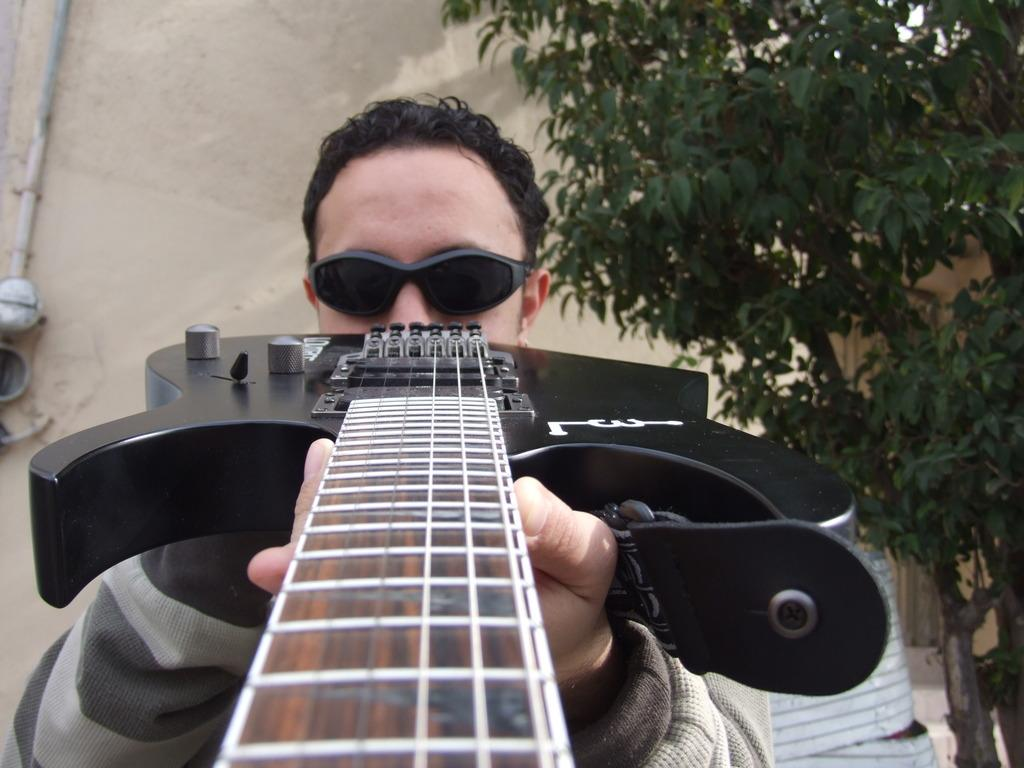What is the main subject of the image? There is a man in the image. What is the man holding in the image? The man is holding a guitar. What can be seen on the right side of the man? There is a tree on the right side of the man. What color is the ink on the toad in the image? There is no toad or ink present in the image. 